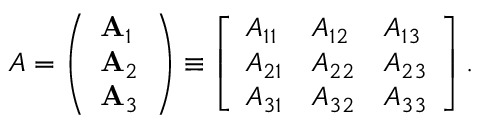<formula> <loc_0><loc_0><loc_500><loc_500>A = \left ( \begin{array} { l } { A _ { 1 } } \\ { A _ { 2 } } \\ { A _ { 3 } } \end{array} \right ) \equiv \left [ \begin{array} { l l l } { A _ { 1 1 } } & { A _ { 1 2 } } & { A _ { 1 3 } } \\ { A _ { 2 1 } } & { A _ { 2 2 } } & { A _ { 2 3 } } \\ { A _ { 3 1 } } & { A _ { 3 2 } } & { A _ { 3 3 } } \end{array} \right ] .</formula> 